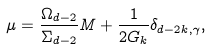<formula> <loc_0><loc_0><loc_500><loc_500>\ \mu = \frac { \Omega _ { d - 2 } } { \Sigma _ { d - 2 } } M + \frac { 1 } { 2 G _ { k } } \delta _ { d - 2 k , \gamma } ,</formula> 